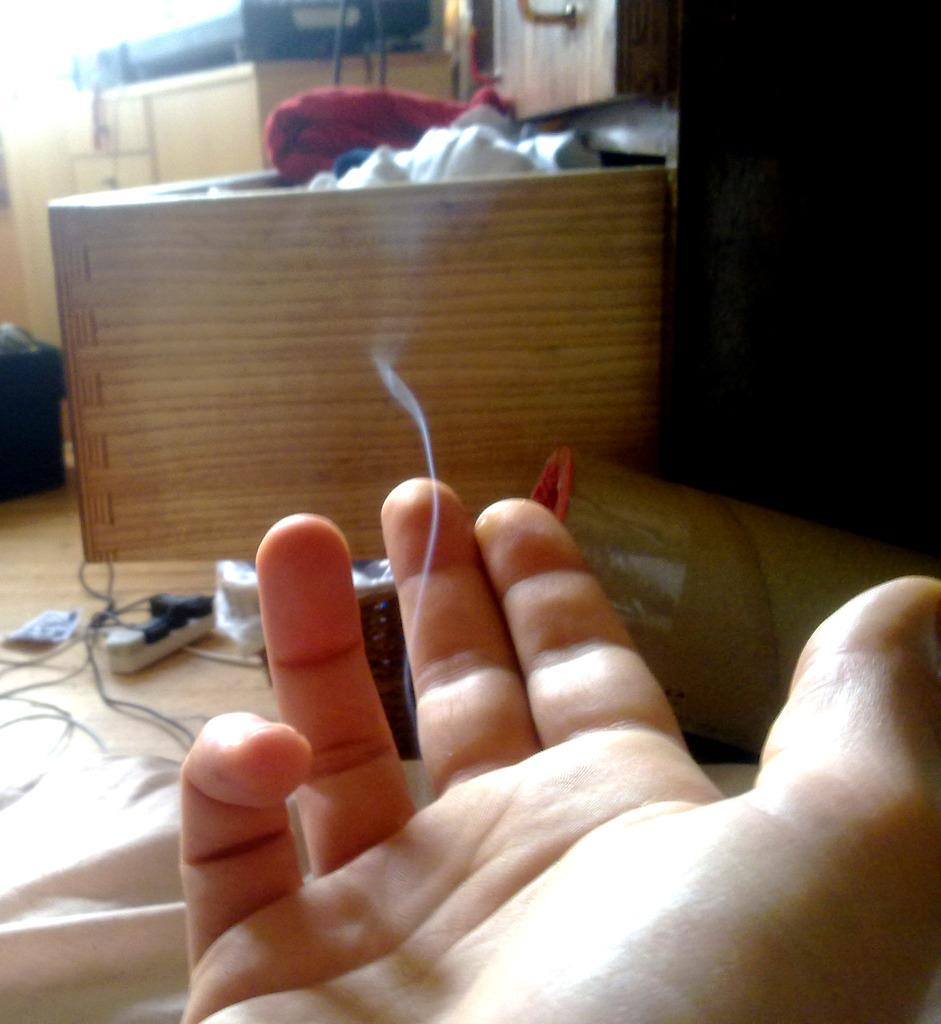What part of the human body is visible in the image? There is a person's palm hand in the image. What type of furniture can be seen in the background of the image? There is a wooden cupboard in the background of the image. What is stored inside the wooden cupboard? Clothes are present in the wooden cupboard. What is on the floor in the image? Electrical cables are on the floor in the image. What type of ornament is hanging from the train in the image? There is no train or ornament present in the image. 